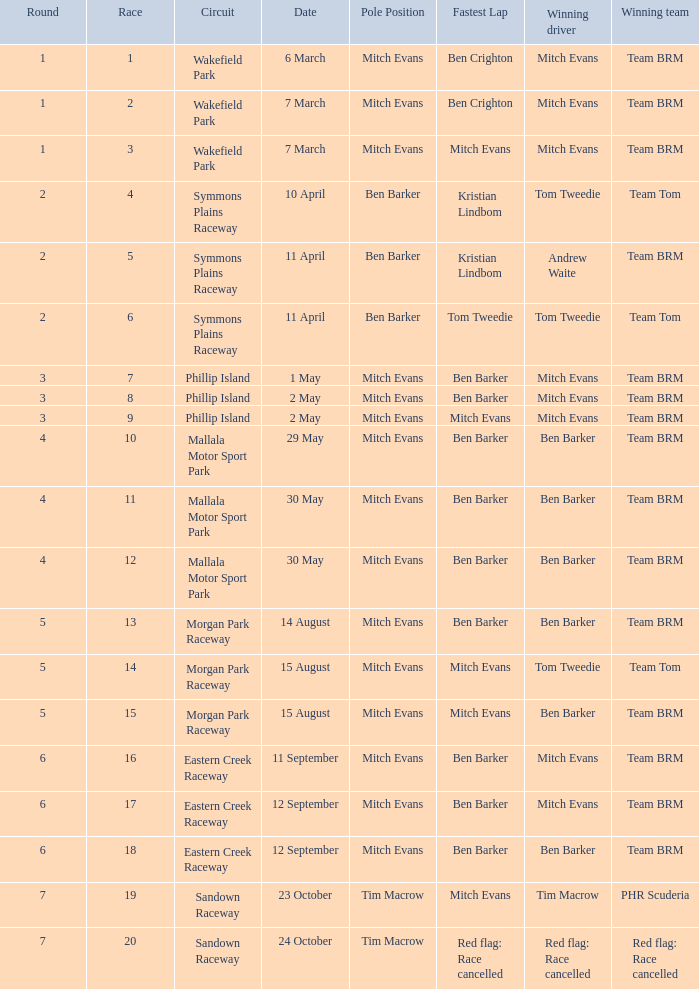What team won Race 17? Team BRM. Help me parse the entirety of this table. {'header': ['Round', 'Race', 'Circuit', 'Date', 'Pole Position', 'Fastest Lap', 'Winning driver', 'Winning team'], 'rows': [['1', '1', 'Wakefield Park', '6 March', 'Mitch Evans', 'Ben Crighton', 'Mitch Evans', 'Team BRM'], ['1', '2', 'Wakefield Park', '7 March', 'Mitch Evans', 'Ben Crighton', 'Mitch Evans', 'Team BRM'], ['1', '3', 'Wakefield Park', '7 March', 'Mitch Evans', 'Mitch Evans', 'Mitch Evans', 'Team BRM'], ['2', '4', 'Symmons Plains Raceway', '10 April', 'Ben Barker', 'Kristian Lindbom', 'Tom Tweedie', 'Team Tom'], ['2', '5', 'Symmons Plains Raceway', '11 April', 'Ben Barker', 'Kristian Lindbom', 'Andrew Waite', 'Team BRM'], ['2', '6', 'Symmons Plains Raceway', '11 April', 'Ben Barker', 'Tom Tweedie', 'Tom Tweedie', 'Team Tom'], ['3', '7', 'Phillip Island', '1 May', 'Mitch Evans', 'Ben Barker', 'Mitch Evans', 'Team BRM'], ['3', '8', 'Phillip Island', '2 May', 'Mitch Evans', 'Ben Barker', 'Mitch Evans', 'Team BRM'], ['3', '9', 'Phillip Island', '2 May', 'Mitch Evans', 'Mitch Evans', 'Mitch Evans', 'Team BRM'], ['4', '10', 'Mallala Motor Sport Park', '29 May', 'Mitch Evans', 'Ben Barker', 'Ben Barker', 'Team BRM'], ['4', '11', 'Mallala Motor Sport Park', '30 May', 'Mitch Evans', 'Ben Barker', 'Ben Barker', 'Team BRM'], ['4', '12', 'Mallala Motor Sport Park', '30 May', 'Mitch Evans', 'Ben Barker', 'Ben Barker', 'Team BRM'], ['5', '13', 'Morgan Park Raceway', '14 August', 'Mitch Evans', 'Ben Barker', 'Ben Barker', 'Team BRM'], ['5', '14', 'Morgan Park Raceway', '15 August', 'Mitch Evans', 'Mitch Evans', 'Tom Tweedie', 'Team Tom'], ['5', '15', 'Morgan Park Raceway', '15 August', 'Mitch Evans', 'Mitch Evans', 'Ben Barker', 'Team BRM'], ['6', '16', 'Eastern Creek Raceway', '11 September', 'Mitch Evans', 'Ben Barker', 'Mitch Evans', 'Team BRM'], ['6', '17', 'Eastern Creek Raceway', '12 September', 'Mitch Evans', 'Ben Barker', 'Mitch Evans', 'Team BRM'], ['6', '18', 'Eastern Creek Raceway', '12 September', 'Mitch Evans', 'Ben Barker', 'Ben Barker', 'Team BRM'], ['7', '19', 'Sandown Raceway', '23 October', 'Tim Macrow', 'Mitch Evans', 'Tim Macrow', 'PHR Scuderia'], ['7', '20', 'Sandown Raceway', '24 October', 'Tim Macrow', 'Red flag: Race cancelled', 'Red flag: Race cancelled', 'Red flag: Race cancelled']]} 